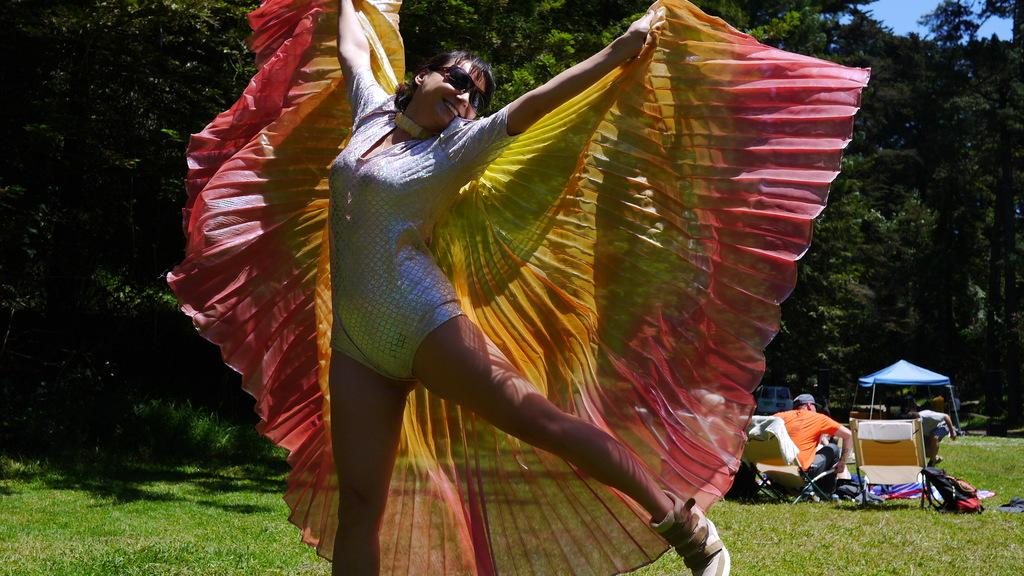What is the main subject of the image? There is a woman in the image. What is the woman doing in the image? The woman is jumping and smiling in the image. What type of structure can be seen in the image? There is a tent in the image. What type of furniture is present in the image? There are chairs in the image. What type of personal item is visible in the image? There is a bag in the image. What type of clothing can be seen in the image? There are clothes in the image. What type of transportation is present in the image? There is a vehicle in the image. What type of natural environment is visible in the image? There are trees in the image. How many people are present in the image? There are people in the image. What is visible in the background of the image? The sky is visible in the background of the image. What type of bridge can be seen crossing the river in the image? There is no bridge or river present in the image. What is the current temperature in the image? The image does not provide information about the temperature. 